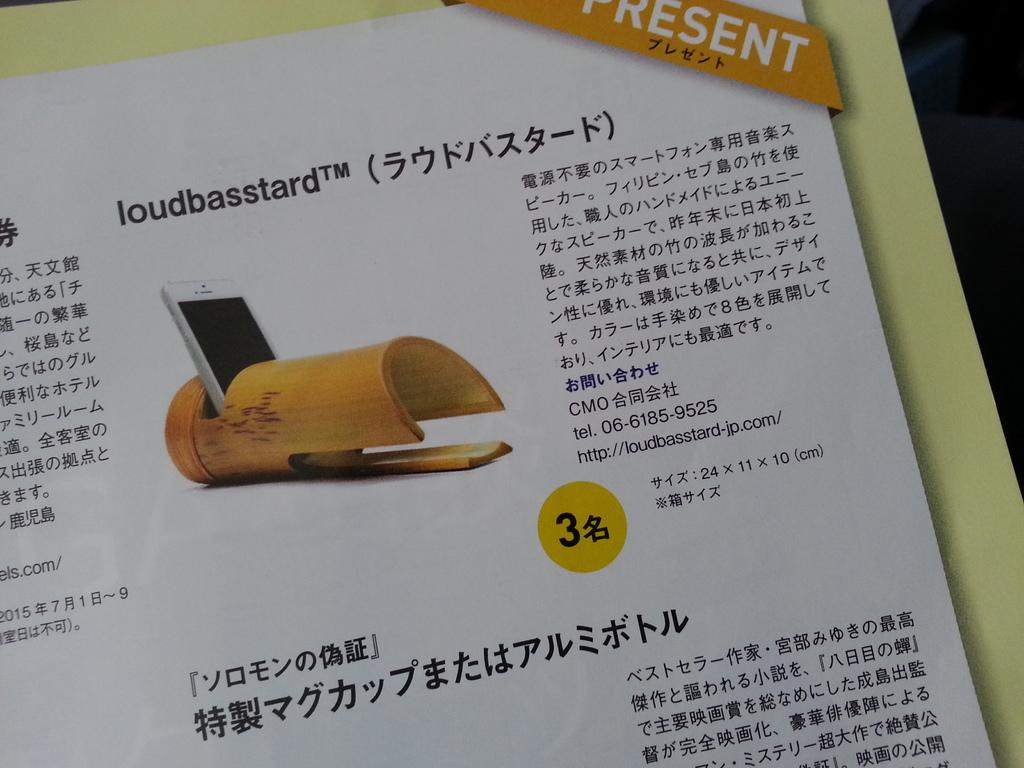<image>
Provide a brief description of the given image. The product in the device is called the loudbasstard 